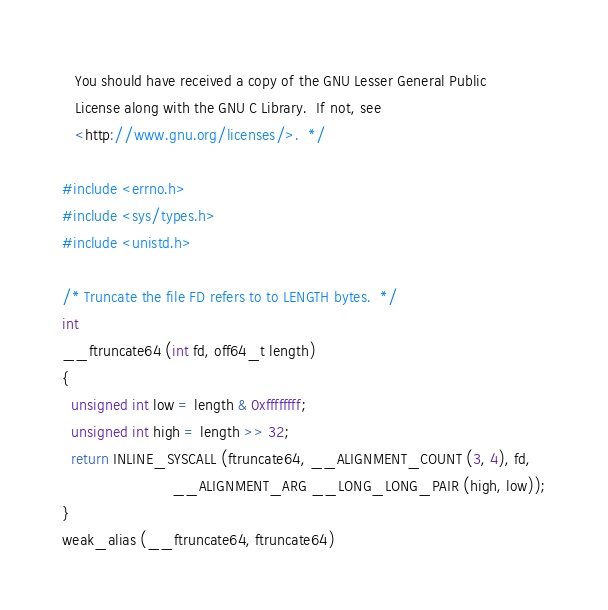<code> <loc_0><loc_0><loc_500><loc_500><_C_>   You should have received a copy of the GNU Lesser General Public
   License along with the GNU C Library.  If not, see
   <http://www.gnu.org/licenses/>.  */

#include <errno.h>
#include <sys/types.h>
#include <unistd.h>

/* Truncate the file FD refers to to LENGTH bytes.  */
int
__ftruncate64 (int fd, off64_t length)
{
  unsigned int low = length & 0xffffffff;
  unsigned int high = length >> 32;
  return INLINE_SYSCALL (ftruncate64, __ALIGNMENT_COUNT (3, 4), fd,
                         __ALIGNMENT_ARG __LONG_LONG_PAIR (high, low));
}
weak_alias (__ftruncate64, ftruncate64)
</code> 